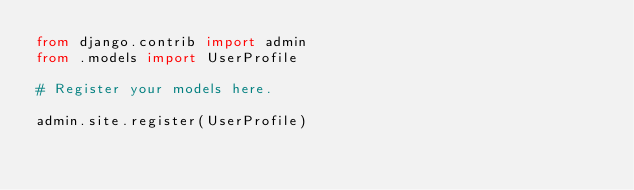<code> <loc_0><loc_0><loc_500><loc_500><_Python_>from django.contrib import admin
from .models import UserProfile

# Register your models here.

admin.site.register(UserProfile)
</code> 